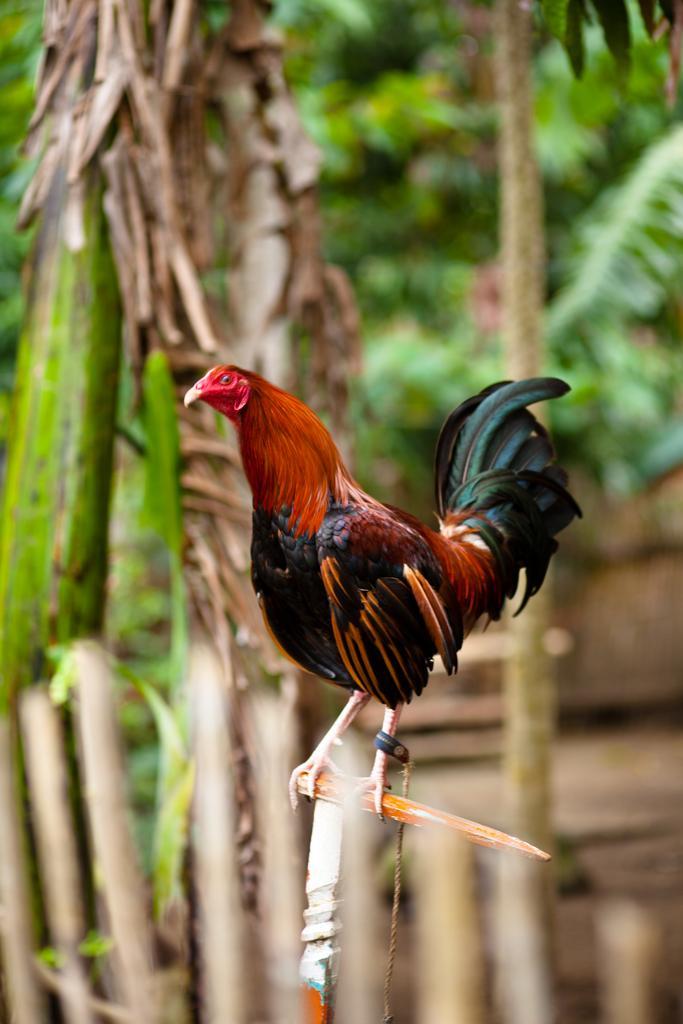In one or two sentences, can you explain what this image depicts? In this image we can see a hen and there is a thread tied to one of the leg and it is holding a stick with its legs and they are on a stick. In the background we can see trees on the ground. 